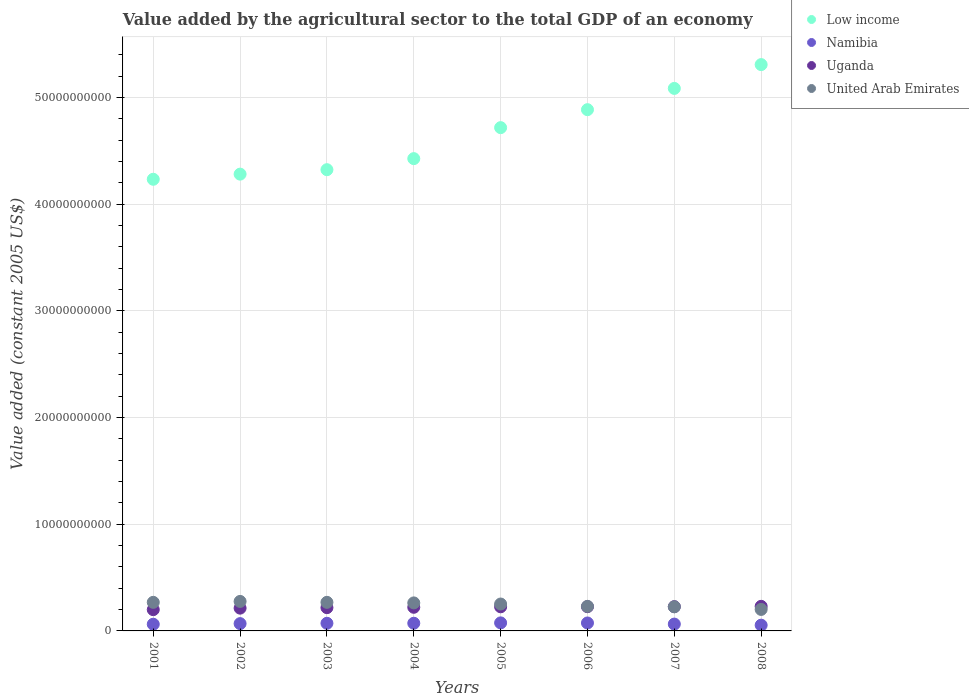How many different coloured dotlines are there?
Offer a terse response. 4. What is the value added by the agricultural sector in Low income in 2005?
Your answer should be very brief. 4.72e+1. Across all years, what is the maximum value added by the agricultural sector in Low income?
Give a very brief answer. 5.31e+1. Across all years, what is the minimum value added by the agricultural sector in United Arab Emirates?
Your response must be concise. 2.01e+09. In which year was the value added by the agricultural sector in Low income maximum?
Offer a terse response. 2008. In which year was the value added by the agricultural sector in Low income minimum?
Keep it short and to the point. 2001. What is the total value added by the agricultural sector in Uganda in the graph?
Offer a very short reply. 1.76e+1. What is the difference between the value added by the agricultural sector in Uganda in 2002 and that in 2004?
Offer a terse response. -8.03e+07. What is the difference between the value added by the agricultural sector in Namibia in 2004 and the value added by the agricultural sector in Low income in 2003?
Provide a short and direct response. -4.25e+1. What is the average value added by the agricultural sector in United Arab Emirates per year?
Keep it short and to the point. 2.48e+09. In the year 2004, what is the difference between the value added by the agricultural sector in Uganda and value added by the agricultural sector in United Arab Emirates?
Offer a terse response. -4.11e+08. What is the ratio of the value added by the agricultural sector in Low income in 2004 to that in 2005?
Provide a succinct answer. 0.94. Is the difference between the value added by the agricultural sector in Uganda in 2003 and 2006 greater than the difference between the value added by the agricultural sector in United Arab Emirates in 2003 and 2006?
Provide a short and direct response. No. What is the difference between the highest and the second highest value added by the agricultural sector in Uganda?
Offer a very short reply. 3.06e+07. What is the difference between the highest and the lowest value added by the agricultural sector in Uganda?
Provide a short and direct response. 3.10e+08. In how many years, is the value added by the agricultural sector in Uganda greater than the average value added by the agricultural sector in Uganda taken over all years?
Provide a short and direct response. 5. Is the sum of the value added by the agricultural sector in Namibia in 2001 and 2007 greater than the maximum value added by the agricultural sector in Uganda across all years?
Provide a short and direct response. No. Is it the case that in every year, the sum of the value added by the agricultural sector in Low income and value added by the agricultural sector in United Arab Emirates  is greater than the sum of value added by the agricultural sector in Namibia and value added by the agricultural sector in Uganda?
Offer a terse response. Yes. Is it the case that in every year, the sum of the value added by the agricultural sector in United Arab Emirates and value added by the agricultural sector in Low income  is greater than the value added by the agricultural sector in Namibia?
Your answer should be very brief. Yes. Does the value added by the agricultural sector in Namibia monotonically increase over the years?
Ensure brevity in your answer.  No. How many years are there in the graph?
Provide a succinct answer. 8. What is the difference between two consecutive major ticks on the Y-axis?
Give a very brief answer. 1.00e+1. Does the graph contain any zero values?
Provide a succinct answer. No. Where does the legend appear in the graph?
Give a very brief answer. Top right. How are the legend labels stacked?
Provide a short and direct response. Vertical. What is the title of the graph?
Ensure brevity in your answer.  Value added by the agricultural sector to the total GDP of an economy. What is the label or title of the Y-axis?
Your answer should be very brief. Value added (constant 2005 US$). What is the Value added (constant 2005 US$) in Low income in 2001?
Offer a terse response. 4.23e+1. What is the Value added (constant 2005 US$) of Namibia in 2001?
Give a very brief answer. 6.26e+08. What is the Value added (constant 2005 US$) in Uganda in 2001?
Provide a succinct answer. 1.99e+09. What is the Value added (constant 2005 US$) of United Arab Emirates in 2001?
Keep it short and to the point. 2.68e+09. What is the Value added (constant 2005 US$) of Low income in 2002?
Your answer should be very brief. 4.28e+1. What is the Value added (constant 2005 US$) in Namibia in 2002?
Ensure brevity in your answer.  6.85e+08. What is the Value added (constant 2005 US$) of Uganda in 2002?
Provide a succinct answer. 2.13e+09. What is the Value added (constant 2005 US$) in United Arab Emirates in 2002?
Make the answer very short. 2.76e+09. What is the Value added (constant 2005 US$) in Low income in 2003?
Provide a short and direct response. 4.32e+1. What is the Value added (constant 2005 US$) in Namibia in 2003?
Your answer should be compact. 7.16e+08. What is the Value added (constant 2005 US$) in Uganda in 2003?
Ensure brevity in your answer.  2.18e+09. What is the Value added (constant 2005 US$) in United Arab Emirates in 2003?
Keep it short and to the point. 2.68e+09. What is the Value added (constant 2005 US$) in Low income in 2004?
Ensure brevity in your answer.  4.43e+1. What is the Value added (constant 2005 US$) in Namibia in 2004?
Offer a terse response. 7.20e+08. What is the Value added (constant 2005 US$) of Uganda in 2004?
Ensure brevity in your answer.  2.21e+09. What is the Value added (constant 2005 US$) in United Arab Emirates in 2004?
Give a very brief answer. 2.63e+09. What is the Value added (constant 2005 US$) of Low income in 2005?
Your answer should be very brief. 4.72e+1. What is the Value added (constant 2005 US$) of Namibia in 2005?
Your answer should be very brief. 7.54e+08. What is the Value added (constant 2005 US$) in Uganda in 2005?
Make the answer very short. 2.26e+09. What is the Value added (constant 2005 US$) in United Arab Emirates in 2005?
Keep it short and to the point. 2.52e+09. What is the Value added (constant 2005 US$) of Low income in 2006?
Your response must be concise. 4.88e+1. What is the Value added (constant 2005 US$) in Namibia in 2006?
Provide a short and direct response. 7.45e+08. What is the Value added (constant 2005 US$) in Uganda in 2006?
Provide a short and direct response. 2.27e+09. What is the Value added (constant 2005 US$) in United Arab Emirates in 2006?
Ensure brevity in your answer.  2.30e+09. What is the Value added (constant 2005 US$) of Low income in 2007?
Provide a short and direct response. 5.08e+1. What is the Value added (constant 2005 US$) in Namibia in 2007?
Offer a terse response. 6.41e+08. What is the Value added (constant 2005 US$) in Uganda in 2007?
Keep it short and to the point. 2.27e+09. What is the Value added (constant 2005 US$) of United Arab Emirates in 2007?
Provide a succinct answer. 2.26e+09. What is the Value added (constant 2005 US$) in Low income in 2008?
Your answer should be compact. 5.31e+1. What is the Value added (constant 2005 US$) of Namibia in 2008?
Provide a succinct answer. 5.39e+08. What is the Value added (constant 2005 US$) of Uganda in 2008?
Your answer should be very brief. 2.30e+09. What is the Value added (constant 2005 US$) in United Arab Emirates in 2008?
Give a very brief answer. 2.01e+09. Across all years, what is the maximum Value added (constant 2005 US$) in Low income?
Provide a short and direct response. 5.31e+1. Across all years, what is the maximum Value added (constant 2005 US$) in Namibia?
Your response must be concise. 7.54e+08. Across all years, what is the maximum Value added (constant 2005 US$) in Uganda?
Ensure brevity in your answer.  2.30e+09. Across all years, what is the maximum Value added (constant 2005 US$) in United Arab Emirates?
Provide a short and direct response. 2.76e+09. Across all years, what is the minimum Value added (constant 2005 US$) of Low income?
Provide a succinct answer. 4.23e+1. Across all years, what is the minimum Value added (constant 2005 US$) of Namibia?
Make the answer very short. 5.39e+08. Across all years, what is the minimum Value added (constant 2005 US$) of Uganda?
Keep it short and to the point. 1.99e+09. Across all years, what is the minimum Value added (constant 2005 US$) in United Arab Emirates?
Provide a succinct answer. 2.01e+09. What is the total Value added (constant 2005 US$) in Low income in the graph?
Your answer should be compact. 3.73e+11. What is the total Value added (constant 2005 US$) in Namibia in the graph?
Your answer should be compact. 5.43e+09. What is the total Value added (constant 2005 US$) of Uganda in the graph?
Keep it short and to the point. 1.76e+1. What is the total Value added (constant 2005 US$) of United Arab Emirates in the graph?
Keep it short and to the point. 1.98e+1. What is the difference between the Value added (constant 2005 US$) in Low income in 2001 and that in 2002?
Your answer should be very brief. -4.82e+08. What is the difference between the Value added (constant 2005 US$) in Namibia in 2001 and that in 2002?
Provide a short and direct response. -5.86e+07. What is the difference between the Value added (constant 2005 US$) of Uganda in 2001 and that in 2002?
Your answer should be very brief. -1.41e+08. What is the difference between the Value added (constant 2005 US$) of United Arab Emirates in 2001 and that in 2002?
Provide a succinct answer. -8.60e+07. What is the difference between the Value added (constant 2005 US$) of Low income in 2001 and that in 2003?
Give a very brief answer. -8.99e+08. What is the difference between the Value added (constant 2005 US$) of Namibia in 2001 and that in 2003?
Ensure brevity in your answer.  -8.93e+07. What is the difference between the Value added (constant 2005 US$) of Uganda in 2001 and that in 2003?
Provide a short and direct response. -1.87e+08. What is the difference between the Value added (constant 2005 US$) in United Arab Emirates in 2001 and that in 2003?
Your answer should be very brief. 0. What is the difference between the Value added (constant 2005 US$) in Low income in 2001 and that in 2004?
Your answer should be very brief. -1.94e+09. What is the difference between the Value added (constant 2005 US$) in Namibia in 2001 and that in 2004?
Provide a short and direct response. -9.38e+07. What is the difference between the Value added (constant 2005 US$) in Uganda in 2001 and that in 2004?
Offer a terse response. -2.21e+08. What is the difference between the Value added (constant 2005 US$) in United Arab Emirates in 2001 and that in 2004?
Offer a very short reply. 5.28e+07. What is the difference between the Value added (constant 2005 US$) in Low income in 2001 and that in 2005?
Ensure brevity in your answer.  -4.84e+09. What is the difference between the Value added (constant 2005 US$) in Namibia in 2001 and that in 2005?
Give a very brief answer. -1.27e+08. What is the difference between the Value added (constant 2005 US$) of Uganda in 2001 and that in 2005?
Give a very brief answer. -2.67e+08. What is the difference between the Value added (constant 2005 US$) in United Arab Emirates in 2001 and that in 2005?
Provide a succinct answer. 1.58e+08. What is the difference between the Value added (constant 2005 US$) in Low income in 2001 and that in 2006?
Your answer should be compact. -6.52e+09. What is the difference between the Value added (constant 2005 US$) in Namibia in 2001 and that in 2006?
Offer a terse response. -1.19e+08. What is the difference between the Value added (constant 2005 US$) of Uganda in 2001 and that in 2006?
Offer a terse response. -2.77e+08. What is the difference between the Value added (constant 2005 US$) of United Arab Emirates in 2001 and that in 2006?
Your response must be concise. 3.76e+08. What is the difference between the Value added (constant 2005 US$) in Low income in 2001 and that in 2007?
Provide a short and direct response. -8.52e+09. What is the difference between the Value added (constant 2005 US$) of Namibia in 2001 and that in 2007?
Your response must be concise. -1.44e+07. What is the difference between the Value added (constant 2005 US$) of Uganda in 2001 and that in 2007?
Offer a terse response. -2.80e+08. What is the difference between the Value added (constant 2005 US$) in United Arab Emirates in 2001 and that in 2007?
Offer a very short reply. 4.19e+08. What is the difference between the Value added (constant 2005 US$) of Low income in 2001 and that in 2008?
Make the answer very short. -1.07e+1. What is the difference between the Value added (constant 2005 US$) in Namibia in 2001 and that in 2008?
Keep it short and to the point. 8.74e+07. What is the difference between the Value added (constant 2005 US$) of Uganda in 2001 and that in 2008?
Provide a short and direct response. -3.10e+08. What is the difference between the Value added (constant 2005 US$) of United Arab Emirates in 2001 and that in 2008?
Your answer should be compact. 6.65e+08. What is the difference between the Value added (constant 2005 US$) in Low income in 2002 and that in 2003?
Keep it short and to the point. -4.17e+08. What is the difference between the Value added (constant 2005 US$) of Namibia in 2002 and that in 2003?
Keep it short and to the point. -3.07e+07. What is the difference between the Value added (constant 2005 US$) in Uganda in 2002 and that in 2003?
Provide a succinct answer. -4.57e+07. What is the difference between the Value added (constant 2005 US$) of United Arab Emirates in 2002 and that in 2003?
Provide a succinct answer. 8.60e+07. What is the difference between the Value added (constant 2005 US$) in Low income in 2002 and that in 2004?
Keep it short and to the point. -1.45e+09. What is the difference between the Value added (constant 2005 US$) of Namibia in 2002 and that in 2004?
Give a very brief answer. -3.52e+07. What is the difference between the Value added (constant 2005 US$) in Uganda in 2002 and that in 2004?
Keep it short and to the point. -8.03e+07. What is the difference between the Value added (constant 2005 US$) in United Arab Emirates in 2002 and that in 2004?
Provide a short and direct response. 1.39e+08. What is the difference between the Value added (constant 2005 US$) of Low income in 2002 and that in 2005?
Provide a succinct answer. -4.36e+09. What is the difference between the Value added (constant 2005 US$) in Namibia in 2002 and that in 2005?
Offer a terse response. -6.85e+07. What is the difference between the Value added (constant 2005 US$) in Uganda in 2002 and that in 2005?
Your answer should be compact. -1.26e+08. What is the difference between the Value added (constant 2005 US$) in United Arab Emirates in 2002 and that in 2005?
Your answer should be very brief. 2.44e+08. What is the difference between the Value added (constant 2005 US$) of Low income in 2002 and that in 2006?
Offer a very short reply. -6.04e+09. What is the difference between the Value added (constant 2005 US$) of Namibia in 2002 and that in 2006?
Your response must be concise. -6.00e+07. What is the difference between the Value added (constant 2005 US$) in Uganda in 2002 and that in 2006?
Provide a short and direct response. -1.36e+08. What is the difference between the Value added (constant 2005 US$) in United Arab Emirates in 2002 and that in 2006?
Give a very brief answer. 4.62e+08. What is the difference between the Value added (constant 2005 US$) in Low income in 2002 and that in 2007?
Offer a terse response. -8.03e+09. What is the difference between the Value added (constant 2005 US$) of Namibia in 2002 and that in 2007?
Provide a short and direct response. 4.42e+07. What is the difference between the Value added (constant 2005 US$) in Uganda in 2002 and that in 2007?
Keep it short and to the point. -1.39e+08. What is the difference between the Value added (constant 2005 US$) in United Arab Emirates in 2002 and that in 2007?
Your answer should be very brief. 5.05e+08. What is the difference between the Value added (constant 2005 US$) in Low income in 2002 and that in 2008?
Provide a succinct answer. -1.03e+1. What is the difference between the Value added (constant 2005 US$) in Namibia in 2002 and that in 2008?
Offer a very short reply. 1.46e+08. What is the difference between the Value added (constant 2005 US$) in Uganda in 2002 and that in 2008?
Your response must be concise. -1.69e+08. What is the difference between the Value added (constant 2005 US$) in United Arab Emirates in 2002 and that in 2008?
Offer a terse response. 7.51e+08. What is the difference between the Value added (constant 2005 US$) in Low income in 2003 and that in 2004?
Your answer should be compact. -1.04e+09. What is the difference between the Value added (constant 2005 US$) in Namibia in 2003 and that in 2004?
Provide a succinct answer. -4.52e+06. What is the difference between the Value added (constant 2005 US$) in Uganda in 2003 and that in 2004?
Your response must be concise. -3.46e+07. What is the difference between the Value added (constant 2005 US$) in United Arab Emirates in 2003 and that in 2004?
Offer a terse response. 5.28e+07. What is the difference between the Value added (constant 2005 US$) in Low income in 2003 and that in 2005?
Ensure brevity in your answer.  -3.94e+09. What is the difference between the Value added (constant 2005 US$) in Namibia in 2003 and that in 2005?
Your response must be concise. -3.79e+07. What is the difference between the Value added (constant 2005 US$) in Uganda in 2003 and that in 2005?
Offer a terse response. -8.00e+07. What is the difference between the Value added (constant 2005 US$) in United Arab Emirates in 2003 and that in 2005?
Your answer should be compact. 1.58e+08. What is the difference between the Value added (constant 2005 US$) in Low income in 2003 and that in 2006?
Your answer should be compact. -5.62e+09. What is the difference between the Value added (constant 2005 US$) in Namibia in 2003 and that in 2006?
Provide a succinct answer. -2.93e+07. What is the difference between the Value added (constant 2005 US$) in Uganda in 2003 and that in 2006?
Offer a terse response. -9.04e+07. What is the difference between the Value added (constant 2005 US$) in United Arab Emirates in 2003 and that in 2006?
Provide a succinct answer. 3.76e+08. What is the difference between the Value added (constant 2005 US$) of Low income in 2003 and that in 2007?
Offer a terse response. -7.62e+09. What is the difference between the Value added (constant 2005 US$) of Namibia in 2003 and that in 2007?
Your answer should be compact. 7.49e+07. What is the difference between the Value added (constant 2005 US$) in Uganda in 2003 and that in 2007?
Offer a very short reply. -9.31e+07. What is the difference between the Value added (constant 2005 US$) of United Arab Emirates in 2003 and that in 2007?
Your response must be concise. 4.19e+08. What is the difference between the Value added (constant 2005 US$) of Low income in 2003 and that in 2008?
Make the answer very short. -9.85e+09. What is the difference between the Value added (constant 2005 US$) of Namibia in 2003 and that in 2008?
Your answer should be very brief. 1.77e+08. What is the difference between the Value added (constant 2005 US$) in Uganda in 2003 and that in 2008?
Give a very brief answer. -1.24e+08. What is the difference between the Value added (constant 2005 US$) of United Arab Emirates in 2003 and that in 2008?
Your answer should be compact. 6.65e+08. What is the difference between the Value added (constant 2005 US$) in Low income in 2004 and that in 2005?
Ensure brevity in your answer.  -2.90e+09. What is the difference between the Value added (constant 2005 US$) of Namibia in 2004 and that in 2005?
Your response must be concise. -3.33e+07. What is the difference between the Value added (constant 2005 US$) in Uganda in 2004 and that in 2005?
Your response must be concise. -4.54e+07. What is the difference between the Value added (constant 2005 US$) of United Arab Emirates in 2004 and that in 2005?
Your answer should be compact. 1.06e+08. What is the difference between the Value added (constant 2005 US$) of Low income in 2004 and that in 2006?
Your answer should be compact. -4.59e+09. What is the difference between the Value added (constant 2005 US$) in Namibia in 2004 and that in 2006?
Make the answer very short. -2.48e+07. What is the difference between the Value added (constant 2005 US$) in Uganda in 2004 and that in 2006?
Offer a terse response. -5.58e+07. What is the difference between the Value added (constant 2005 US$) in United Arab Emirates in 2004 and that in 2006?
Give a very brief answer. 3.23e+08. What is the difference between the Value added (constant 2005 US$) of Low income in 2004 and that in 2007?
Offer a very short reply. -6.58e+09. What is the difference between the Value added (constant 2005 US$) of Namibia in 2004 and that in 2007?
Provide a short and direct response. 7.94e+07. What is the difference between the Value added (constant 2005 US$) in Uganda in 2004 and that in 2007?
Provide a short and direct response. -5.85e+07. What is the difference between the Value added (constant 2005 US$) of United Arab Emirates in 2004 and that in 2007?
Your answer should be very brief. 3.66e+08. What is the difference between the Value added (constant 2005 US$) of Low income in 2004 and that in 2008?
Provide a succinct answer. -8.81e+09. What is the difference between the Value added (constant 2005 US$) of Namibia in 2004 and that in 2008?
Make the answer very short. 1.81e+08. What is the difference between the Value added (constant 2005 US$) of Uganda in 2004 and that in 2008?
Keep it short and to the point. -8.91e+07. What is the difference between the Value added (constant 2005 US$) in United Arab Emirates in 2004 and that in 2008?
Keep it short and to the point. 6.12e+08. What is the difference between the Value added (constant 2005 US$) of Low income in 2005 and that in 2006?
Give a very brief answer. -1.68e+09. What is the difference between the Value added (constant 2005 US$) in Namibia in 2005 and that in 2006?
Ensure brevity in your answer.  8.55e+06. What is the difference between the Value added (constant 2005 US$) in Uganda in 2005 and that in 2006?
Your answer should be very brief. -1.04e+07. What is the difference between the Value added (constant 2005 US$) of United Arab Emirates in 2005 and that in 2006?
Your answer should be very brief. 2.18e+08. What is the difference between the Value added (constant 2005 US$) of Low income in 2005 and that in 2007?
Provide a short and direct response. -3.68e+09. What is the difference between the Value added (constant 2005 US$) in Namibia in 2005 and that in 2007?
Provide a short and direct response. 1.13e+08. What is the difference between the Value added (constant 2005 US$) of Uganda in 2005 and that in 2007?
Offer a very short reply. -1.31e+07. What is the difference between the Value added (constant 2005 US$) of United Arab Emirates in 2005 and that in 2007?
Provide a short and direct response. 2.60e+08. What is the difference between the Value added (constant 2005 US$) in Low income in 2005 and that in 2008?
Ensure brevity in your answer.  -5.91e+09. What is the difference between the Value added (constant 2005 US$) of Namibia in 2005 and that in 2008?
Ensure brevity in your answer.  2.15e+08. What is the difference between the Value added (constant 2005 US$) in Uganda in 2005 and that in 2008?
Provide a succinct answer. -4.37e+07. What is the difference between the Value added (constant 2005 US$) in United Arab Emirates in 2005 and that in 2008?
Provide a short and direct response. 5.06e+08. What is the difference between the Value added (constant 2005 US$) of Low income in 2006 and that in 2007?
Your answer should be very brief. -1.99e+09. What is the difference between the Value added (constant 2005 US$) in Namibia in 2006 and that in 2007?
Ensure brevity in your answer.  1.04e+08. What is the difference between the Value added (constant 2005 US$) in Uganda in 2006 and that in 2007?
Ensure brevity in your answer.  -2.71e+06. What is the difference between the Value added (constant 2005 US$) of United Arab Emirates in 2006 and that in 2007?
Your response must be concise. 4.25e+07. What is the difference between the Value added (constant 2005 US$) in Low income in 2006 and that in 2008?
Your answer should be compact. -4.22e+09. What is the difference between the Value added (constant 2005 US$) of Namibia in 2006 and that in 2008?
Your answer should be very brief. 2.06e+08. What is the difference between the Value added (constant 2005 US$) in Uganda in 2006 and that in 2008?
Your answer should be very brief. -3.33e+07. What is the difference between the Value added (constant 2005 US$) in United Arab Emirates in 2006 and that in 2008?
Keep it short and to the point. 2.89e+08. What is the difference between the Value added (constant 2005 US$) in Low income in 2007 and that in 2008?
Keep it short and to the point. -2.23e+09. What is the difference between the Value added (constant 2005 US$) of Namibia in 2007 and that in 2008?
Your response must be concise. 1.02e+08. What is the difference between the Value added (constant 2005 US$) of Uganda in 2007 and that in 2008?
Give a very brief answer. -3.06e+07. What is the difference between the Value added (constant 2005 US$) of United Arab Emirates in 2007 and that in 2008?
Ensure brevity in your answer.  2.46e+08. What is the difference between the Value added (constant 2005 US$) in Low income in 2001 and the Value added (constant 2005 US$) in Namibia in 2002?
Provide a succinct answer. 4.16e+1. What is the difference between the Value added (constant 2005 US$) in Low income in 2001 and the Value added (constant 2005 US$) in Uganda in 2002?
Offer a very short reply. 4.02e+1. What is the difference between the Value added (constant 2005 US$) of Low income in 2001 and the Value added (constant 2005 US$) of United Arab Emirates in 2002?
Keep it short and to the point. 3.96e+1. What is the difference between the Value added (constant 2005 US$) of Namibia in 2001 and the Value added (constant 2005 US$) of Uganda in 2002?
Keep it short and to the point. -1.51e+09. What is the difference between the Value added (constant 2005 US$) of Namibia in 2001 and the Value added (constant 2005 US$) of United Arab Emirates in 2002?
Offer a very short reply. -2.14e+09. What is the difference between the Value added (constant 2005 US$) of Uganda in 2001 and the Value added (constant 2005 US$) of United Arab Emirates in 2002?
Offer a terse response. -7.71e+08. What is the difference between the Value added (constant 2005 US$) in Low income in 2001 and the Value added (constant 2005 US$) in Namibia in 2003?
Offer a terse response. 4.16e+1. What is the difference between the Value added (constant 2005 US$) of Low income in 2001 and the Value added (constant 2005 US$) of Uganda in 2003?
Provide a succinct answer. 4.01e+1. What is the difference between the Value added (constant 2005 US$) in Low income in 2001 and the Value added (constant 2005 US$) in United Arab Emirates in 2003?
Offer a terse response. 3.96e+1. What is the difference between the Value added (constant 2005 US$) in Namibia in 2001 and the Value added (constant 2005 US$) in Uganda in 2003?
Your answer should be very brief. -1.55e+09. What is the difference between the Value added (constant 2005 US$) in Namibia in 2001 and the Value added (constant 2005 US$) in United Arab Emirates in 2003?
Offer a very short reply. -2.05e+09. What is the difference between the Value added (constant 2005 US$) of Uganda in 2001 and the Value added (constant 2005 US$) of United Arab Emirates in 2003?
Your answer should be compact. -6.85e+08. What is the difference between the Value added (constant 2005 US$) of Low income in 2001 and the Value added (constant 2005 US$) of Namibia in 2004?
Provide a short and direct response. 4.16e+1. What is the difference between the Value added (constant 2005 US$) in Low income in 2001 and the Value added (constant 2005 US$) in Uganda in 2004?
Provide a succinct answer. 4.01e+1. What is the difference between the Value added (constant 2005 US$) in Low income in 2001 and the Value added (constant 2005 US$) in United Arab Emirates in 2004?
Give a very brief answer. 3.97e+1. What is the difference between the Value added (constant 2005 US$) in Namibia in 2001 and the Value added (constant 2005 US$) in Uganda in 2004?
Provide a succinct answer. -1.59e+09. What is the difference between the Value added (constant 2005 US$) of Namibia in 2001 and the Value added (constant 2005 US$) of United Arab Emirates in 2004?
Your answer should be very brief. -2.00e+09. What is the difference between the Value added (constant 2005 US$) of Uganda in 2001 and the Value added (constant 2005 US$) of United Arab Emirates in 2004?
Give a very brief answer. -6.32e+08. What is the difference between the Value added (constant 2005 US$) in Low income in 2001 and the Value added (constant 2005 US$) in Namibia in 2005?
Provide a succinct answer. 4.16e+1. What is the difference between the Value added (constant 2005 US$) of Low income in 2001 and the Value added (constant 2005 US$) of Uganda in 2005?
Provide a short and direct response. 4.01e+1. What is the difference between the Value added (constant 2005 US$) of Low income in 2001 and the Value added (constant 2005 US$) of United Arab Emirates in 2005?
Your response must be concise. 3.98e+1. What is the difference between the Value added (constant 2005 US$) in Namibia in 2001 and the Value added (constant 2005 US$) in Uganda in 2005?
Give a very brief answer. -1.63e+09. What is the difference between the Value added (constant 2005 US$) of Namibia in 2001 and the Value added (constant 2005 US$) of United Arab Emirates in 2005?
Provide a short and direct response. -1.89e+09. What is the difference between the Value added (constant 2005 US$) in Uganda in 2001 and the Value added (constant 2005 US$) in United Arab Emirates in 2005?
Provide a succinct answer. -5.27e+08. What is the difference between the Value added (constant 2005 US$) of Low income in 2001 and the Value added (constant 2005 US$) of Namibia in 2006?
Your answer should be compact. 4.16e+1. What is the difference between the Value added (constant 2005 US$) in Low income in 2001 and the Value added (constant 2005 US$) in Uganda in 2006?
Offer a terse response. 4.01e+1. What is the difference between the Value added (constant 2005 US$) of Low income in 2001 and the Value added (constant 2005 US$) of United Arab Emirates in 2006?
Make the answer very short. 4.00e+1. What is the difference between the Value added (constant 2005 US$) of Namibia in 2001 and the Value added (constant 2005 US$) of Uganda in 2006?
Offer a terse response. -1.64e+09. What is the difference between the Value added (constant 2005 US$) in Namibia in 2001 and the Value added (constant 2005 US$) in United Arab Emirates in 2006?
Offer a very short reply. -1.68e+09. What is the difference between the Value added (constant 2005 US$) in Uganda in 2001 and the Value added (constant 2005 US$) in United Arab Emirates in 2006?
Provide a succinct answer. -3.09e+08. What is the difference between the Value added (constant 2005 US$) in Low income in 2001 and the Value added (constant 2005 US$) in Namibia in 2007?
Make the answer very short. 4.17e+1. What is the difference between the Value added (constant 2005 US$) in Low income in 2001 and the Value added (constant 2005 US$) in Uganda in 2007?
Keep it short and to the point. 4.01e+1. What is the difference between the Value added (constant 2005 US$) in Low income in 2001 and the Value added (constant 2005 US$) in United Arab Emirates in 2007?
Give a very brief answer. 4.01e+1. What is the difference between the Value added (constant 2005 US$) in Namibia in 2001 and the Value added (constant 2005 US$) in Uganda in 2007?
Make the answer very short. -1.65e+09. What is the difference between the Value added (constant 2005 US$) in Namibia in 2001 and the Value added (constant 2005 US$) in United Arab Emirates in 2007?
Your response must be concise. -1.63e+09. What is the difference between the Value added (constant 2005 US$) in Uganda in 2001 and the Value added (constant 2005 US$) in United Arab Emirates in 2007?
Offer a terse response. -2.67e+08. What is the difference between the Value added (constant 2005 US$) of Low income in 2001 and the Value added (constant 2005 US$) of Namibia in 2008?
Your answer should be compact. 4.18e+1. What is the difference between the Value added (constant 2005 US$) in Low income in 2001 and the Value added (constant 2005 US$) in Uganda in 2008?
Keep it short and to the point. 4.00e+1. What is the difference between the Value added (constant 2005 US$) in Low income in 2001 and the Value added (constant 2005 US$) in United Arab Emirates in 2008?
Make the answer very short. 4.03e+1. What is the difference between the Value added (constant 2005 US$) in Namibia in 2001 and the Value added (constant 2005 US$) in Uganda in 2008?
Keep it short and to the point. -1.68e+09. What is the difference between the Value added (constant 2005 US$) in Namibia in 2001 and the Value added (constant 2005 US$) in United Arab Emirates in 2008?
Your answer should be very brief. -1.39e+09. What is the difference between the Value added (constant 2005 US$) of Uganda in 2001 and the Value added (constant 2005 US$) of United Arab Emirates in 2008?
Make the answer very short. -2.03e+07. What is the difference between the Value added (constant 2005 US$) in Low income in 2002 and the Value added (constant 2005 US$) in Namibia in 2003?
Your response must be concise. 4.21e+1. What is the difference between the Value added (constant 2005 US$) in Low income in 2002 and the Value added (constant 2005 US$) in Uganda in 2003?
Provide a succinct answer. 4.06e+1. What is the difference between the Value added (constant 2005 US$) in Low income in 2002 and the Value added (constant 2005 US$) in United Arab Emirates in 2003?
Offer a very short reply. 4.01e+1. What is the difference between the Value added (constant 2005 US$) in Namibia in 2002 and the Value added (constant 2005 US$) in Uganda in 2003?
Ensure brevity in your answer.  -1.50e+09. What is the difference between the Value added (constant 2005 US$) of Namibia in 2002 and the Value added (constant 2005 US$) of United Arab Emirates in 2003?
Your response must be concise. -1.99e+09. What is the difference between the Value added (constant 2005 US$) of Uganda in 2002 and the Value added (constant 2005 US$) of United Arab Emirates in 2003?
Your answer should be very brief. -5.44e+08. What is the difference between the Value added (constant 2005 US$) of Low income in 2002 and the Value added (constant 2005 US$) of Namibia in 2004?
Provide a succinct answer. 4.21e+1. What is the difference between the Value added (constant 2005 US$) of Low income in 2002 and the Value added (constant 2005 US$) of Uganda in 2004?
Give a very brief answer. 4.06e+1. What is the difference between the Value added (constant 2005 US$) of Low income in 2002 and the Value added (constant 2005 US$) of United Arab Emirates in 2004?
Your answer should be compact. 4.02e+1. What is the difference between the Value added (constant 2005 US$) of Namibia in 2002 and the Value added (constant 2005 US$) of Uganda in 2004?
Provide a short and direct response. -1.53e+09. What is the difference between the Value added (constant 2005 US$) in Namibia in 2002 and the Value added (constant 2005 US$) in United Arab Emirates in 2004?
Provide a succinct answer. -1.94e+09. What is the difference between the Value added (constant 2005 US$) in Uganda in 2002 and the Value added (constant 2005 US$) in United Arab Emirates in 2004?
Offer a very short reply. -4.91e+08. What is the difference between the Value added (constant 2005 US$) in Low income in 2002 and the Value added (constant 2005 US$) in Namibia in 2005?
Offer a terse response. 4.21e+1. What is the difference between the Value added (constant 2005 US$) of Low income in 2002 and the Value added (constant 2005 US$) of Uganda in 2005?
Make the answer very short. 4.05e+1. What is the difference between the Value added (constant 2005 US$) of Low income in 2002 and the Value added (constant 2005 US$) of United Arab Emirates in 2005?
Your answer should be compact. 4.03e+1. What is the difference between the Value added (constant 2005 US$) of Namibia in 2002 and the Value added (constant 2005 US$) of Uganda in 2005?
Offer a very short reply. -1.58e+09. What is the difference between the Value added (constant 2005 US$) of Namibia in 2002 and the Value added (constant 2005 US$) of United Arab Emirates in 2005?
Keep it short and to the point. -1.84e+09. What is the difference between the Value added (constant 2005 US$) of Uganda in 2002 and the Value added (constant 2005 US$) of United Arab Emirates in 2005?
Your answer should be compact. -3.86e+08. What is the difference between the Value added (constant 2005 US$) of Low income in 2002 and the Value added (constant 2005 US$) of Namibia in 2006?
Your response must be concise. 4.21e+1. What is the difference between the Value added (constant 2005 US$) of Low income in 2002 and the Value added (constant 2005 US$) of Uganda in 2006?
Ensure brevity in your answer.  4.05e+1. What is the difference between the Value added (constant 2005 US$) in Low income in 2002 and the Value added (constant 2005 US$) in United Arab Emirates in 2006?
Provide a short and direct response. 4.05e+1. What is the difference between the Value added (constant 2005 US$) in Namibia in 2002 and the Value added (constant 2005 US$) in Uganda in 2006?
Offer a terse response. -1.59e+09. What is the difference between the Value added (constant 2005 US$) in Namibia in 2002 and the Value added (constant 2005 US$) in United Arab Emirates in 2006?
Provide a succinct answer. -1.62e+09. What is the difference between the Value added (constant 2005 US$) in Uganda in 2002 and the Value added (constant 2005 US$) in United Arab Emirates in 2006?
Provide a succinct answer. -1.68e+08. What is the difference between the Value added (constant 2005 US$) in Low income in 2002 and the Value added (constant 2005 US$) in Namibia in 2007?
Your answer should be very brief. 4.22e+1. What is the difference between the Value added (constant 2005 US$) in Low income in 2002 and the Value added (constant 2005 US$) in Uganda in 2007?
Your answer should be very brief. 4.05e+1. What is the difference between the Value added (constant 2005 US$) of Low income in 2002 and the Value added (constant 2005 US$) of United Arab Emirates in 2007?
Your answer should be very brief. 4.05e+1. What is the difference between the Value added (constant 2005 US$) of Namibia in 2002 and the Value added (constant 2005 US$) of Uganda in 2007?
Make the answer very short. -1.59e+09. What is the difference between the Value added (constant 2005 US$) of Namibia in 2002 and the Value added (constant 2005 US$) of United Arab Emirates in 2007?
Give a very brief answer. -1.58e+09. What is the difference between the Value added (constant 2005 US$) of Uganda in 2002 and the Value added (constant 2005 US$) of United Arab Emirates in 2007?
Your answer should be very brief. -1.26e+08. What is the difference between the Value added (constant 2005 US$) of Low income in 2002 and the Value added (constant 2005 US$) of Namibia in 2008?
Provide a short and direct response. 4.23e+1. What is the difference between the Value added (constant 2005 US$) in Low income in 2002 and the Value added (constant 2005 US$) in Uganda in 2008?
Provide a short and direct response. 4.05e+1. What is the difference between the Value added (constant 2005 US$) of Low income in 2002 and the Value added (constant 2005 US$) of United Arab Emirates in 2008?
Make the answer very short. 4.08e+1. What is the difference between the Value added (constant 2005 US$) of Namibia in 2002 and the Value added (constant 2005 US$) of Uganda in 2008?
Your answer should be compact. -1.62e+09. What is the difference between the Value added (constant 2005 US$) in Namibia in 2002 and the Value added (constant 2005 US$) in United Arab Emirates in 2008?
Ensure brevity in your answer.  -1.33e+09. What is the difference between the Value added (constant 2005 US$) of Uganda in 2002 and the Value added (constant 2005 US$) of United Arab Emirates in 2008?
Make the answer very short. 1.21e+08. What is the difference between the Value added (constant 2005 US$) in Low income in 2003 and the Value added (constant 2005 US$) in Namibia in 2004?
Keep it short and to the point. 4.25e+1. What is the difference between the Value added (constant 2005 US$) in Low income in 2003 and the Value added (constant 2005 US$) in Uganda in 2004?
Provide a short and direct response. 4.10e+1. What is the difference between the Value added (constant 2005 US$) in Low income in 2003 and the Value added (constant 2005 US$) in United Arab Emirates in 2004?
Offer a very short reply. 4.06e+1. What is the difference between the Value added (constant 2005 US$) in Namibia in 2003 and the Value added (constant 2005 US$) in Uganda in 2004?
Provide a short and direct response. -1.50e+09. What is the difference between the Value added (constant 2005 US$) of Namibia in 2003 and the Value added (constant 2005 US$) of United Arab Emirates in 2004?
Provide a succinct answer. -1.91e+09. What is the difference between the Value added (constant 2005 US$) in Uganda in 2003 and the Value added (constant 2005 US$) in United Arab Emirates in 2004?
Ensure brevity in your answer.  -4.46e+08. What is the difference between the Value added (constant 2005 US$) of Low income in 2003 and the Value added (constant 2005 US$) of Namibia in 2005?
Your answer should be very brief. 4.25e+1. What is the difference between the Value added (constant 2005 US$) of Low income in 2003 and the Value added (constant 2005 US$) of Uganda in 2005?
Make the answer very short. 4.10e+1. What is the difference between the Value added (constant 2005 US$) of Low income in 2003 and the Value added (constant 2005 US$) of United Arab Emirates in 2005?
Your answer should be very brief. 4.07e+1. What is the difference between the Value added (constant 2005 US$) in Namibia in 2003 and the Value added (constant 2005 US$) in Uganda in 2005?
Give a very brief answer. -1.54e+09. What is the difference between the Value added (constant 2005 US$) of Namibia in 2003 and the Value added (constant 2005 US$) of United Arab Emirates in 2005?
Provide a short and direct response. -1.80e+09. What is the difference between the Value added (constant 2005 US$) in Uganda in 2003 and the Value added (constant 2005 US$) in United Arab Emirates in 2005?
Provide a succinct answer. -3.40e+08. What is the difference between the Value added (constant 2005 US$) of Low income in 2003 and the Value added (constant 2005 US$) of Namibia in 2006?
Provide a short and direct response. 4.25e+1. What is the difference between the Value added (constant 2005 US$) in Low income in 2003 and the Value added (constant 2005 US$) in Uganda in 2006?
Provide a short and direct response. 4.10e+1. What is the difference between the Value added (constant 2005 US$) in Low income in 2003 and the Value added (constant 2005 US$) in United Arab Emirates in 2006?
Make the answer very short. 4.09e+1. What is the difference between the Value added (constant 2005 US$) of Namibia in 2003 and the Value added (constant 2005 US$) of Uganda in 2006?
Offer a terse response. -1.55e+09. What is the difference between the Value added (constant 2005 US$) of Namibia in 2003 and the Value added (constant 2005 US$) of United Arab Emirates in 2006?
Offer a terse response. -1.59e+09. What is the difference between the Value added (constant 2005 US$) in Uganda in 2003 and the Value added (constant 2005 US$) in United Arab Emirates in 2006?
Your answer should be very brief. -1.22e+08. What is the difference between the Value added (constant 2005 US$) in Low income in 2003 and the Value added (constant 2005 US$) in Namibia in 2007?
Your response must be concise. 4.26e+1. What is the difference between the Value added (constant 2005 US$) in Low income in 2003 and the Value added (constant 2005 US$) in Uganda in 2007?
Your response must be concise. 4.10e+1. What is the difference between the Value added (constant 2005 US$) in Low income in 2003 and the Value added (constant 2005 US$) in United Arab Emirates in 2007?
Offer a terse response. 4.10e+1. What is the difference between the Value added (constant 2005 US$) in Namibia in 2003 and the Value added (constant 2005 US$) in Uganda in 2007?
Give a very brief answer. -1.56e+09. What is the difference between the Value added (constant 2005 US$) of Namibia in 2003 and the Value added (constant 2005 US$) of United Arab Emirates in 2007?
Give a very brief answer. -1.54e+09. What is the difference between the Value added (constant 2005 US$) in Uganda in 2003 and the Value added (constant 2005 US$) in United Arab Emirates in 2007?
Offer a very short reply. -8.00e+07. What is the difference between the Value added (constant 2005 US$) of Low income in 2003 and the Value added (constant 2005 US$) of Namibia in 2008?
Give a very brief answer. 4.27e+1. What is the difference between the Value added (constant 2005 US$) of Low income in 2003 and the Value added (constant 2005 US$) of Uganda in 2008?
Keep it short and to the point. 4.09e+1. What is the difference between the Value added (constant 2005 US$) of Low income in 2003 and the Value added (constant 2005 US$) of United Arab Emirates in 2008?
Provide a short and direct response. 4.12e+1. What is the difference between the Value added (constant 2005 US$) in Namibia in 2003 and the Value added (constant 2005 US$) in Uganda in 2008?
Offer a very short reply. -1.59e+09. What is the difference between the Value added (constant 2005 US$) of Namibia in 2003 and the Value added (constant 2005 US$) of United Arab Emirates in 2008?
Give a very brief answer. -1.30e+09. What is the difference between the Value added (constant 2005 US$) of Uganda in 2003 and the Value added (constant 2005 US$) of United Arab Emirates in 2008?
Provide a short and direct response. 1.66e+08. What is the difference between the Value added (constant 2005 US$) of Low income in 2004 and the Value added (constant 2005 US$) of Namibia in 2005?
Provide a succinct answer. 4.35e+1. What is the difference between the Value added (constant 2005 US$) of Low income in 2004 and the Value added (constant 2005 US$) of Uganda in 2005?
Your response must be concise. 4.20e+1. What is the difference between the Value added (constant 2005 US$) in Low income in 2004 and the Value added (constant 2005 US$) in United Arab Emirates in 2005?
Ensure brevity in your answer.  4.17e+1. What is the difference between the Value added (constant 2005 US$) in Namibia in 2004 and the Value added (constant 2005 US$) in Uganda in 2005?
Keep it short and to the point. -1.54e+09. What is the difference between the Value added (constant 2005 US$) in Namibia in 2004 and the Value added (constant 2005 US$) in United Arab Emirates in 2005?
Provide a short and direct response. -1.80e+09. What is the difference between the Value added (constant 2005 US$) in Uganda in 2004 and the Value added (constant 2005 US$) in United Arab Emirates in 2005?
Provide a short and direct response. -3.06e+08. What is the difference between the Value added (constant 2005 US$) in Low income in 2004 and the Value added (constant 2005 US$) in Namibia in 2006?
Give a very brief answer. 4.35e+1. What is the difference between the Value added (constant 2005 US$) of Low income in 2004 and the Value added (constant 2005 US$) of Uganda in 2006?
Offer a very short reply. 4.20e+1. What is the difference between the Value added (constant 2005 US$) in Low income in 2004 and the Value added (constant 2005 US$) in United Arab Emirates in 2006?
Offer a very short reply. 4.20e+1. What is the difference between the Value added (constant 2005 US$) of Namibia in 2004 and the Value added (constant 2005 US$) of Uganda in 2006?
Keep it short and to the point. -1.55e+09. What is the difference between the Value added (constant 2005 US$) of Namibia in 2004 and the Value added (constant 2005 US$) of United Arab Emirates in 2006?
Provide a succinct answer. -1.58e+09. What is the difference between the Value added (constant 2005 US$) in Uganda in 2004 and the Value added (constant 2005 US$) in United Arab Emirates in 2006?
Provide a short and direct response. -8.78e+07. What is the difference between the Value added (constant 2005 US$) in Low income in 2004 and the Value added (constant 2005 US$) in Namibia in 2007?
Offer a terse response. 4.36e+1. What is the difference between the Value added (constant 2005 US$) in Low income in 2004 and the Value added (constant 2005 US$) in Uganda in 2007?
Your answer should be very brief. 4.20e+1. What is the difference between the Value added (constant 2005 US$) of Low income in 2004 and the Value added (constant 2005 US$) of United Arab Emirates in 2007?
Keep it short and to the point. 4.20e+1. What is the difference between the Value added (constant 2005 US$) of Namibia in 2004 and the Value added (constant 2005 US$) of Uganda in 2007?
Provide a short and direct response. -1.55e+09. What is the difference between the Value added (constant 2005 US$) of Namibia in 2004 and the Value added (constant 2005 US$) of United Arab Emirates in 2007?
Your answer should be very brief. -1.54e+09. What is the difference between the Value added (constant 2005 US$) in Uganda in 2004 and the Value added (constant 2005 US$) in United Arab Emirates in 2007?
Offer a very short reply. -4.53e+07. What is the difference between the Value added (constant 2005 US$) in Low income in 2004 and the Value added (constant 2005 US$) in Namibia in 2008?
Make the answer very short. 4.37e+1. What is the difference between the Value added (constant 2005 US$) of Low income in 2004 and the Value added (constant 2005 US$) of Uganda in 2008?
Make the answer very short. 4.20e+1. What is the difference between the Value added (constant 2005 US$) in Low income in 2004 and the Value added (constant 2005 US$) in United Arab Emirates in 2008?
Provide a succinct answer. 4.22e+1. What is the difference between the Value added (constant 2005 US$) in Namibia in 2004 and the Value added (constant 2005 US$) in Uganda in 2008?
Your answer should be compact. -1.58e+09. What is the difference between the Value added (constant 2005 US$) in Namibia in 2004 and the Value added (constant 2005 US$) in United Arab Emirates in 2008?
Your answer should be very brief. -1.29e+09. What is the difference between the Value added (constant 2005 US$) of Uganda in 2004 and the Value added (constant 2005 US$) of United Arab Emirates in 2008?
Offer a terse response. 2.01e+08. What is the difference between the Value added (constant 2005 US$) of Low income in 2005 and the Value added (constant 2005 US$) of Namibia in 2006?
Ensure brevity in your answer.  4.64e+1. What is the difference between the Value added (constant 2005 US$) in Low income in 2005 and the Value added (constant 2005 US$) in Uganda in 2006?
Ensure brevity in your answer.  4.49e+1. What is the difference between the Value added (constant 2005 US$) in Low income in 2005 and the Value added (constant 2005 US$) in United Arab Emirates in 2006?
Provide a succinct answer. 4.49e+1. What is the difference between the Value added (constant 2005 US$) in Namibia in 2005 and the Value added (constant 2005 US$) in Uganda in 2006?
Your answer should be compact. -1.52e+09. What is the difference between the Value added (constant 2005 US$) in Namibia in 2005 and the Value added (constant 2005 US$) in United Arab Emirates in 2006?
Ensure brevity in your answer.  -1.55e+09. What is the difference between the Value added (constant 2005 US$) of Uganda in 2005 and the Value added (constant 2005 US$) of United Arab Emirates in 2006?
Give a very brief answer. -4.25e+07. What is the difference between the Value added (constant 2005 US$) of Low income in 2005 and the Value added (constant 2005 US$) of Namibia in 2007?
Your answer should be compact. 4.65e+1. What is the difference between the Value added (constant 2005 US$) in Low income in 2005 and the Value added (constant 2005 US$) in Uganda in 2007?
Your answer should be compact. 4.49e+1. What is the difference between the Value added (constant 2005 US$) in Low income in 2005 and the Value added (constant 2005 US$) in United Arab Emirates in 2007?
Ensure brevity in your answer.  4.49e+1. What is the difference between the Value added (constant 2005 US$) in Namibia in 2005 and the Value added (constant 2005 US$) in Uganda in 2007?
Offer a very short reply. -1.52e+09. What is the difference between the Value added (constant 2005 US$) of Namibia in 2005 and the Value added (constant 2005 US$) of United Arab Emirates in 2007?
Make the answer very short. -1.51e+09. What is the difference between the Value added (constant 2005 US$) in Uganda in 2005 and the Value added (constant 2005 US$) in United Arab Emirates in 2007?
Provide a succinct answer. 5.48e+04. What is the difference between the Value added (constant 2005 US$) of Low income in 2005 and the Value added (constant 2005 US$) of Namibia in 2008?
Provide a short and direct response. 4.66e+1. What is the difference between the Value added (constant 2005 US$) in Low income in 2005 and the Value added (constant 2005 US$) in Uganda in 2008?
Provide a short and direct response. 4.49e+1. What is the difference between the Value added (constant 2005 US$) of Low income in 2005 and the Value added (constant 2005 US$) of United Arab Emirates in 2008?
Offer a terse response. 4.52e+1. What is the difference between the Value added (constant 2005 US$) of Namibia in 2005 and the Value added (constant 2005 US$) of Uganda in 2008?
Your answer should be compact. -1.55e+09. What is the difference between the Value added (constant 2005 US$) of Namibia in 2005 and the Value added (constant 2005 US$) of United Arab Emirates in 2008?
Ensure brevity in your answer.  -1.26e+09. What is the difference between the Value added (constant 2005 US$) of Uganda in 2005 and the Value added (constant 2005 US$) of United Arab Emirates in 2008?
Offer a very short reply. 2.46e+08. What is the difference between the Value added (constant 2005 US$) of Low income in 2006 and the Value added (constant 2005 US$) of Namibia in 2007?
Your response must be concise. 4.82e+1. What is the difference between the Value added (constant 2005 US$) in Low income in 2006 and the Value added (constant 2005 US$) in Uganda in 2007?
Offer a very short reply. 4.66e+1. What is the difference between the Value added (constant 2005 US$) in Low income in 2006 and the Value added (constant 2005 US$) in United Arab Emirates in 2007?
Your response must be concise. 4.66e+1. What is the difference between the Value added (constant 2005 US$) in Namibia in 2006 and the Value added (constant 2005 US$) in Uganda in 2007?
Ensure brevity in your answer.  -1.53e+09. What is the difference between the Value added (constant 2005 US$) in Namibia in 2006 and the Value added (constant 2005 US$) in United Arab Emirates in 2007?
Offer a very short reply. -1.52e+09. What is the difference between the Value added (constant 2005 US$) of Uganda in 2006 and the Value added (constant 2005 US$) of United Arab Emirates in 2007?
Your response must be concise. 1.04e+07. What is the difference between the Value added (constant 2005 US$) of Low income in 2006 and the Value added (constant 2005 US$) of Namibia in 2008?
Provide a short and direct response. 4.83e+1. What is the difference between the Value added (constant 2005 US$) of Low income in 2006 and the Value added (constant 2005 US$) of Uganda in 2008?
Your answer should be very brief. 4.65e+1. What is the difference between the Value added (constant 2005 US$) in Low income in 2006 and the Value added (constant 2005 US$) in United Arab Emirates in 2008?
Your answer should be very brief. 4.68e+1. What is the difference between the Value added (constant 2005 US$) of Namibia in 2006 and the Value added (constant 2005 US$) of Uganda in 2008?
Make the answer very short. -1.56e+09. What is the difference between the Value added (constant 2005 US$) of Namibia in 2006 and the Value added (constant 2005 US$) of United Arab Emirates in 2008?
Keep it short and to the point. -1.27e+09. What is the difference between the Value added (constant 2005 US$) of Uganda in 2006 and the Value added (constant 2005 US$) of United Arab Emirates in 2008?
Give a very brief answer. 2.57e+08. What is the difference between the Value added (constant 2005 US$) of Low income in 2007 and the Value added (constant 2005 US$) of Namibia in 2008?
Keep it short and to the point. 5.03e+1. What is the difference between the Value added (constant 2005 US$) of Low income in 2007 and the Value added (constant 2005 US$) of Uganda in 2008?
Offer a terse response. 4.85e+1. What is the difference between the Value added (constant 2005 US$) of Low income in 2007 and the Value added (constant 2005 US$) of United Arab Emirates in 2008?
Offer a terse response. 4.88e+1. What is the difference between the Value added (constant 2005 US$) of Namibia in 2007 and the Value added (constant 2005 US$) of Uganda in 2008?
Your response must be concise. -1.66e+09. What is the difference between the Value added (constant 2005 US$) of Namibia in 2007 and the Value added (constant 2005 US$) of United Arab Emirates in 2008?
Offer a terse response. -1.37e+09. What is the difference between the Value added (constant 2005 US$) of Uganda in 2007 and the Value added (constant 2005 US$) of United Arab Emirates in 2008?
Your response must be concise. 2.59e+08. What is the average Value added (constant 2005 US$) in Low income per year?
Your answer should be compact. 4.66e+1. What is the average Value added (constant 2005 US$) in Namibia per year?
Offer a terse response. 6.78e+08. What is the average Value added (constant 2005 US$) of Uganda per year?
Your answer should be very brief. 2.20e+09. What is the average Value added (constant 2005 US$) of United Arab Emirates per year?
Make the answer very short. 2.48e+09. In the year 2001, what is the difference between the Value added (constant 2005 US$) of Low income and Value added (constant 2005 US$) of Namibia?
Provide a short and direct response. 4.17e+1. In the year 2001, what is the difference between the Value added (constant 2005 US$) in Low income and Value added (constant 2005 US$) in Uganda?
Make the answer very short. 4.03e+1. In the year 2001, what is the difference between the Value added (constant 2005 US$) in Low income and Value added (constant 2005 US$) in United Arab Emirates?
Your answer should be very brief. 3.96e+1. In the year 2001, what is the difference between the Value added (constant 2005 US$) of Namibia and Value added (constant 2005 US$) of Uganda?
Offer a very short reply. -1.37e+09. In the year 2001, what is the difference between the Value added (constant 2005 US$) of Namibia and Value added (constant 2005 US$) of United Arab Emirates?
Make the answer very short. -2.05e+09. In the year 2001, what is the difference between the Value added (constant 2005 US$) in Uganda and Value added (constant 2005 US$) in United Arab Emirates?
Your answer should be very brief. -6.85e+08. In the year 2002, what is the difference between the Value added (constant 2005 US$) of Low income and Value added (constant 2005 US$) of Namibia?
Your response must be concise. 4.21e+1. In the year 2002, what is the difference between the Value added (constant 2005 US$) of Low income and Value added (constant 2005 US$) of Uganda?
Make the answer very short. 4.07e+1. In the year 2002, what is the difference between the Value added (constant 2005 US$) of Low income and Value added (constant 2005 US$) of United Arab Emirates?
Your answer should be compact. 4.00e+1. In the year 2002, what is the difference between the Value added (constant 2005 US$) in Namibia and Value added (constant 2005 US$) in Uganda?
Provide a succinct answer. -1.45e+09. In the year 2002, what is the difference between the Value added (constant 2005 US$) of Namibia and Value added (constant 2005 US$) of United Arab Emirates?
Provide a short and direct response. -2.08e+09. In the year 2002, what is the difference between the Value added (constant 2005 US$) of Uganda and Value added (constant 2005 US$) of United Arab Emirates?
Offer a very short reply. -6.30e+08. In the year 2003, what is the difference between the Value added (constant 2005 US$) in Low income and Value added (constant 2005 US$) in Namibia?
Your response must be concise. 4.25e+1. In the year 2003, what is the difference between the Value added (constant 2005 US$) in Low income and Value added (constant 2005 US$) in Uganda?
Give a very brief answer. 4.10e+1. In the year 2003, what is the difference between the Value added (constant 2005 US$) in Low income and Value added (constant 2005 US$) in United Arab Emirates?
Ensure brevity in your answer.  4.05e+1. In the year 2003, what is the difference between the Value added (constant 2005 US$) of Namibia and Value added (constant 2005 US$) of Uganda?
Your answer should be very brief. -1.46e+09. In the year 2003, what is the difference between the Value added (constant 2005 US$) in Namibia and Value added (constant 2005 US$) in United Arab Emirates?
Provide a short and direct response. -1.96e+09. In the year 2003, what is the difference between the Value added (constant 2005 US$) of Uganda and Value added (constant 2005 US$) of United Arab Emirates?
Ensure brevity in your answer.  -4.98e+08. In the year 2004, what is the difference between the Value added (constant 2005 US$) in Low income and Value added (constant 2005 US$) in Namibia?
Your answer should be compact. 4.35e+1. In the year 2004, what is the difference between the Value added (constant 2005 US$) of Low income and Value added (constant 2005 US$) of Uganda?
Provide a short and direct response. 4.20e+1. In the year 2004, what is the difference between the Value added (constant 2005 US$) in Low income and Value added (constant 2005 US$) in United Arab Emirates?
Make the answer very short. 4.16e+1. In the year 2004, what is the difference between the Value added (constant 2005 US$) in Namibia and Value added (constant 2005 US$) in Uganda?
Offer a terse response. -1.49e+09. In the year 2004, what is the difference between the Value added (constant 2005 US$) of Namibia and Value added (constant 2005 US$) of United Arab Emirates?
Ensure brevity in your answer.  -1.91e+09. In the year 2004, what is the difference between the Value added (constant 2005 US$) of Uganda and Value added (constant 2005 US$) of United Arab Emirates?
Give a very brief answer. -4.11e+08. In the year 2005, what is the difference between the Value added (constant 2005 US$) of Low income and Value added (constant 2005 US$) of Namibia?
Offer a terse response. 4.64e+1. In the year 2005, what is the difference between the Value added (constant 2005 US$) in Low income and Value added (constant 2005 US$) in Uganda?
Your response must be concise. 4.49e+1. In the year 2005, what is the difference between the Value added (constant 2005 US$) in Low income and Value added (constant 2005 US$) in United Arab Emirates?
Provide a succinct answer. 4.46e+1. In the year 2005, what is the difference between the Value added (constant 2005 US$) in Namibia and Value added (constant 2005 US$) in Uganda?
Give a very brief answer. -1.51e+09. In the year 2005, what is the difference between the Value added (constant 2005 US$) of Namibia and Value added (constant 2005 US$) of United Arab Emirates?
Your response must be concise. -1.77e+09. In the year 2005, what is the difference between the Value added (constant 2005 US$) in Uganda and Value added (constant 2005 US$) in United Arab Emirates?
Your answer should be compact. -2.60e+08. In the year 2006, what is the difference between the Value added (constant 2005 US$) of Low income and Value added (constant 2005 US$) of Namibia?
Offer a very short reply. 4.81e+1. In the year 2006, what is the difference between the Value added (constant 2005 US$) in Low income and Value added (constant 2005 US$) in Uganda?
Your answer should be compact. 4.66e+1. In the year 2006, what is the difference between the Value added (constant 2005 US$) in Low income and Value added (constant 2005 US$) in United Arab Emirates?
Make the answer very short. 4.65e+1. In the year 2006, what is the difference between the Value added (constant 2005 US$) of Namibia and Value added (constant 2005 US$) of Uganda?
Your answer should be compact. -1.53e+09. In the year 2006, what is the difference between the Value added (constant 2005 US$) in Namibia and Value added (constant 2005 US$) in United Arab Emirates?
Offer a terse response. -1.56e+09. In the year 2006, what is the difference between the Value added (constant 2005 US$) of Uganda and Value added (constant 2005 US$) of United Arab Emirates?
Give a very brief answer. -3.21e+07. In the year 2007, what is the difference between the Value added (constant 2005 US$) of Low income and Value added (constant 2005 US$) of Namibia?
Offer a very short reply. 5.02e+1. In the year 2007, what is the difference between the Value added (constant 2005 US$) of Low income and Value added (constant 2005 US$) of Uganda?
Your answer should be very brief. 4.86e+1. In the year 2007, what is the difference between the Value added (constant 2005 US$) in Low income and Value added (constant 2005 US$) in United Arab Emirates?
Offer a terse response. 4.86e+1. In the year 2007, what is the difference between the Value added (constant 2005 US$) in Namibia and Value added (constant 2005 US$) in Uganda?
Keep it short and to the point. -1.63e+09. In the year 2007, what is the difference between the Value added (constant 2005 US$) in Namibia and Value added (constant 2005 US$) in United Arab Emirates?
Give a very brief answer. -1.62e+09. In the year 2007, what is the difference between the Value added (constant 2005 US$) in Uganda and Value added (constant 2005 US$) in United Arab Emirates?
Provide a succinct answer. 1.31e+07. In the year 2008, what is the difference between the Value added (constant 2005 US$) of Low income and Value added (constant 2005 US$) of Namibia?
Your answer should be very brief. 5.25e+1. In the year 2008, what is the difference between the Value added (constant 2005 US$) of Low income and Value added (constant 2005 US$) of Uganda?
Ensure brevity in your answer.  5.08e+1. In the year 2008, what is the difference between the Value added (constant 2005 US$) of Low income and Value added (constant 2005 US$) of United Arab Emirates?
Provide a short and direct response. 5.11e+1. In the year 2008, what is the difference between the Value added (constant 2005 US$) of Namibia and Value added (constant 2005 US$) of Uganda?
Your answer should be very brief. -1.76e+09. In the year 2008, what is the difference between the Value added (constant 2005 US$) in Namibia and Value added (constant 2005 US$) in United Arab Emirates?
Your response must be concise. -1.47e+09. In the year 2008, what is the difference between the Value added (constant 2005 US$) of Uganda and Value added (constant 2005 US$) of United Arab Emirates?
Keep it short and to the point. 2.90e+08. What is the ratio of the Value added (constant 2005 US$) in Namibia in 2001 to that in 2002?
Your answer should be very brief. 0.91. What is the ratio of the Value added (constant 2005 US$) of Uganda in 2001 to that in 2002?
Provide a short and direct response. 0.93. What is the ratio of the Value added (constant 2005 US$) of United Arab Emirates in 2001 to that in 2002?
Keep it short and to the point. 0.97. What is the ratio of the Value added (constant 2005 US$) of Low income in 2001 to that in 2003?
Your answer should be compact. 0.98. What is the ratio of the Value added (constant 2005 US$) in Namibia in 2001 to that in 2003?
Make the answer very short. 0.88. What is the ratio of the Value added (constant 2005 US$) in Uganda in 2001 to that in 2003?
Provide a short and direct response. 0.91. What is the ratio of the Value added (constant 2005 US$) of Low income in 2001 to that in 2004?
Ensure brevity in your answer.  0.96. What is the ratio of the Value added (constant 2005 US$) in Namibia in 2001 to that in 2004?
Offer a terse response. 0.87. What is the ratio of the Value added (constant 2005 US$) in Uganda in 2001 to that in 2004?
Your response must be concise. 0.9. What is the ratio of the Value added (constant 2005 US$) in United Arab Emirates in 2001 to that in 2004?
Provide a succinct answer. 1.02. What is the ratio of the Value added (constant 2005 US$) in Low income in 2001 to that in 2005?
Your answer should be compact. 0.9. What is the ratio of the Value added (constant 2005 US$) in Namibia in 2001 to that in 2005?
Your response must be concise. 0.83. What is the ratio of the Value added (constant 2005 US$) of Uganda in 2001 to that in 2005?
Your answer should be compact. 0.88. What is the ratio of the Value added (constant 2005 US$) in United Arab Emirates in 2001 to that in 2005?
Ensure brevity in your answer.  1.06. What is the ratio of the Value added (constant 2005 US$) of Low income in 2001 to that in 2006?
Keep it short and to the point. 0.87. What is the ratio of the Value added (constant 2005 US$) of Namibia in 2001 to that in 2006?
Give a very brief answer. 0.84. What is the ratio of the Value added (constant 2005 US$) of Uganda in 2001 to that in 2006?
Provide a succinct answer. 0.88. What is the ratio of the Value added (constant 2005 US$) of United Arab Emirates in 2001 to that in 2006?
Provide a short and direct response. 1.16. What is the ratio of the Value added (constant 2005 US$) in Low income in 2001 to that in 2007?
Ensure brevity in your answer.  0.83. What is the ratio of the Value added (constant 2005 US$) of Namibia in 2001 to that in 2007?
Offer a terse response. 0.98. What is the ratio of the Value added (constant 2005 US$) of Uganda in 2001 to that in 2007?
Provide a succinct answer. 0.88. What is the ratio of the Value added (constant 2005 US$) of United Arab Emirates in 2001 to that in 2007?
Offer a very short reply. 1.19. What is the ratio of the Value added (constant 2005 US$) in Low income in 2001 to that in 2008?
Your answer should be compact. 0.8. What is the ratio of the Value added (constant 2005 US$) of Namibia in 2001 to that in 2008?
Your response must be concise. 1.16. What is the ratio of the Value added (constant 2005 US$) of Uganda in 2001 to that in 2008?
Your response must be concise. 0.87. What is the ratio of the Value added (constant 2005 US$) in United Arab Emirates in 2001 to that in 2008?
Provide a short and direct response. 1.33. What is the ratio of the Value added (constant 2005 US$) of Low income in 2002 to that in 2003?
Your answer should be compact. 0.99. What is the ratio of the Value added (constant 2005 US$) in Namibia in 2002 to that in 2003?
Keep it short and to the point. 0.96. What is the ratio of the Value added (constant 2005 US$) of United Arab Emirates in 2002 to that in 2003?
Offer a very short reply. 1.03. What is the ratio of the Value added (constant 2005 US$) of Low income in 2002 to that in 2004?
Offer a terse response. 0.97. What is the ratio of the Value added (constant 2005 US$) in Namibia in 2002 to that in 2004?
Provide a succinct answer. 0.95. What is the ratio of the Value added (constant 2005 US$) in Uganda in 2002 to that in 2004?
Keep it short and to the point. 0.96. What is the ratio of the Value added (constant 2005 US$) in United Arab Emirates in 2002 to that in 2004?
Offer a very short reply. 1.05. What is the ratio of the Value added (constant 2005 US$) in Low income in 2002 to that in 2005?
Make the answer very short. 0.91. What is the ratio of the Value added (constant 2005 US$) in Namibia in 2002 to that in 2005?
Provide a succinct answer. 0.91. What is the ratio of the Value added (constant 2005 US$) of United Arab Emirates in 2002 to that in 2005?
Make the answer very short. 1.1. What is the ratio of the Value added (constant 2005 US$) of Low income in 2002 to that in 2006?
Give a very brief answer. 0.88. What is the ratio of the Value added (constant 2005 US$) of Namibia in 2002 to that in 2006?
Your answer should be very brief. 0.92. What is the ratio of the Value added (constant 2005 US$) of Uganda in 2002 to that in 2006?
Your answer should be very brief. 0.94. What is the ratio of the Value added (constant 2005 US$) in United Arab Emirates in 2002 to that in 2006?
Keep it short and to the point. 1.2. What is the ratio of the Value added (constant 2005 US$) in Low income in 2002 to that in 2007?
Offer a terse response. 0.84. What is the ratio of the Value added (constant 2005 US$) in Namibia in 2002 to that in 2007?
Provide a succinct answer. 1.07. What is the ratio of the Value added (constant 2005 US$) of Uganda in 2002 to that in 2007?
Keep it short and to the point. 0.94. What is the ratio of the Value added (constant 2005 US$) of United Arab Emirates in 2002 to that in 2007?
Keep it short and to the point. 1.22. What is the ratio of the Value added (constant 2005 US$) of Low income in 2002 to that in 2008?
Your answer should be very brief. 0.81. What is the ratio of the Value added (constant 2005 US$) of Namibia in 2002 to that in 2008?
Make the answer very short. 1.27. What is the ratio of the Value added (constant 2005 US$) of Uganda in 2002 to that in 2008?
Keep it short and to the point. 0.93. What is the ratio of the Value added (constant 2005 US$) in United Arab Emirates in 2002 to that in 2008?
Provide a short and direct response. 1.37. What is the ratio of the Value added (constant 2005 US$) in Low income in 2003 to that in 2004?
Provide a short and direct response. 0.98. What is the ratio of the Value added (constant 2005 US$) of Uganda in 2003 to that in 2004?
Give a very brief answer. 0.98. What is the ratio of the Value added (constant 2005 US$) of United Arab Emirates in 2003 to that in 2004?
Your answer should be compact. 1.02. What is the ratio of the Value added (constant 2005 US$) of Low income in 2003 to that in 2005?
Ensure brevity in your answer.  0.92. What is the ratio of the Value added (constant 2005 US$) in Namibia in 2003 to that in 2005?
Offer a very short reply. 0.95. What is the ratio of the Value added (constant 2005 US$) of Uganda in 2003 to that in 2005?
Your answer should be compact. 0.96. What is the ratio of the Value added (constant 2005 US$) in United Arab Emirates in 2003 to that in 2005?
Your answer should be compact. 1.06. What is the ratio of the Value added (constant 2005 US$) of Low income in 2003 to that in 2006?
Your answer should be compact. 0.88. What is the ratio of the Value added (constant 2005 US$) of Namibia in 2003 to that in 2006?
Your response must be concise. 0.96. What is the ratio of the Value added (constant 2005 US$) in Uganda in 2003 to that in 2006?
Provide a succinct answer. 0.96. What is the ratio of the Value added (constant 2005 US$) of United Arab Emirates in 2003 to that in 2006?
Make the answer very short. 1.16. What is the ratio of the Value added (constant 2005 US$) of Low income in 2003 to that in 2007?
Your response must be concise. 0.85. What is the ratio of the Value added (constant 2005 US$) of Namibia in 2003 to that in 2007?
Your response must be concise. 1.12. What is the ratio of the Value added (constant 2005 US$) in Uganda in 2003 to that in 2007?
Provide a short and direct response. 0.96. What is the ratio of the Value added (constant 2005 US$) in United Arab Emirates in 2003 to that in 2007?
Your response must be concise. 1.19. What is the ratio of the Value added (constant 2005 US$) in Low income in 2003 to that in 2008?
Provide a short and direct response. 0.81. What is the ratio of the Value added (constant 2005 US$) of Namibia in 2003 to that in 2008?
Your response must be concise. 1.33. What is the ratio of the Value added (constant 2005 US$) of Uganda in 2003 to that in 2008?
Give a very brief answer. 0.95. What is the ratio of the Value added (constant 2005 US$) of United Arab Emirates in 2003 to that in 2008?
Your answer should be compact. 1.33. What is the ratio of the Value added (constant 2005 US$) in Low income in 2004 to that in 2005?
Your answer should be compact. 0.94. What is the ratio of the Value added (constant 2005 US$) of Namibia in 2004 to that in 2005?
Keep it short and to the point. 0.96. What is the ratio of the Value added (constant 2005 US$) of Uganda in 2004 to that in 2005?
Your answer should be very brief. 0.98. What is the ratio of the Value added (constant 2005 US$) of United Arab Emirates in 2004 to that in 2005?
Offer a very short reply. 1.04. What is the ratio of the Value added (constant 2005 US$) of Low income in 2004 to that in 2006?
Ensure brevity in your answer.  0.91. What is the ratio of the Value added (constant 2005 US$) of Namibia in 2004 to that in 2006?
Offer a very short reply. 0.97. What is the ratio of the Value added (constant 2005 US$) in Uganda in 2004 to that in 2006?
Keep it short and to the point. 0.98. What is the ratio of the Value added (constant 2005 US$) of United Arab Emirates in 2004 to that in 2006?
Provide a short and direct response. 1.14. What is the ratio of the Value added (constant 2005 US$) of Low income in 2004 to that in 2007?
Offer a very short reply. 0.87. What is the ratio of the Value added (constant 2005 US$) in Namibia in 2004 to that in 2007?
Your response must be concise. 1.12. What is the ratio of the Value added (constant 2005 US$) in Uganda in 2004 to that in 2007?
Your answer should be very brief. 0.97. What is the ratio of the Value added (constant 2005 US$) of United Arab Emirates in 2004 to that in 2007?
Keep it short and to the point. 1.16. What is the ratio of the Value added (constant 2005 US$) of Low income in 2004 to that in 2008?
Your response must be concise. 0.83. What is the ratio of the Value added (constant 2005 US$) in Namibia in 2004 to that in 2008?
Ensure brevity in your answer.  1.34. What is the ratio of the Value added (constant 2005 US$) of Uganda in 2004 to that in 2008?
Your answer should be very brief. 0.96. What is the ratio of the Value added (constant 2005 US$) of United Arab Emirates in 2004 to that in 2008?
Offer a terse response. 1.3. What is the ratio of the Value added (constant 2005 US$) in Low income in 2005 to that in 2006?
Keep it short and to the point. 0.97. What is the ratio of the Value added (constant 2005 US$) in Namibia in 2005 to that in 2006?
Provide a short and direct response. 1.01. What is the ratio of the Value added (constant 2005 US$) in Uganda in 2005 to that in 2006?
Your answer should be very brief. 1. What is the ratio of the Value added (constant 2005 US$) in United Arab Emirates in 2005 to that in 2006?
Give a very brief answer. 1.09. What is the ratio of the Value added (constant 2005 US$) of Low income in 2005 to that in 2007?
Provide a short and direct response. 0.93. What is the ratio of the Value added (constant 2005 US$) of Namibia in 2005 to that in 2007?
Provide a short and direct response. 1.18. What is the ratio of the Value added (constant 2005 US$) in Uganda in 2005 to that in 2007?
Provide a succinct answer. 0.99. What is the ratio of the Value added (constant 2005 US$) in United Arab Emirates in 2005 to that in 2007?
Offer a very short reply. 1.12. What is the ratio of the Value added (constant 2005 US$) of Low income in 2005 to that in 2008?
Your answer should be compact. 0.89. What is the ratio of the Value added (constant 2005 US$) of Namibia in 2005 to that in 2008?
Make the answer very short. 1.4. What is the ratio of the Value added (constant 2005 US$) in United Arab Emirates in 2005 to that in 2008?
Provide a succinct answer. 1.25. What is the ratio of the Value added (constant 2005 US$) in Low income in 2006 to that in 2007?
Ensure brevity in your answer.  0.96. What is the ratio of the Value added (constant 2005 US$) in Namibia in 2006 to that in 2007?
Give a very brief answer. 1.16. What is the ratio of the Value added (constant 2005 US$) in Uganda in 2006 to that in 2007?
Provide a succinct answer. 1. What is the ratio of the Value added (constant 2005 US$) of United Arab Emirates in 2006 to that in 2007?
Your answer should be very brief. 1.02. What is the ratio of the Value added (constant 2005 US$) in Low income in 2006 to that in 2008?
Keep it short and to the point. 0.92. What is the ratio of the Value added (constant 2005 US$) in Namibia in 2006 to that in 2008?
Keep it short and to the point. 1.38. What is the ratio of the Value added (constant 2005 US$) in Uganda in 2006 to that in 2008?
Your answer should be compact. 0.99. What is the ratio of the Value added (constant 2005 US$) of United Arab Emirates in 2006 to that in 2008?
Offer a very short reply. 1.14. What is the ratio of the Value added (constant 2005 US$) in Low income in 2007 to that in 2008?
Make the answer very short. 0.96. What is the ratio of the Value added (constant 2005 US$) in Namibia in 2007 to that in 2008?
Your response must be concise. 1.19. What is the ratio of the Value added (constant 2005 US$) of Uganda in 2007 to that in 2008?
Make the answer very short. 0.99. What is the ratio of the Value added (constant 2005 US$) of United Arab Emirates in 2007 to that in 2008?
Your answer should be very brief. 1.12. What is the difference between the highest and the second highest Value added (constant 2005 US$) of Low income?
Offer a very short reply. 2.23e+09. What is the difference between the highest and the second highest Value added (constant 2005 US$) of Namibia?
Provide a short and direct response. 8.55e+06. What is the difference between the highest and the second highest Value added (constant 2005 US$) in Uganda?
Give a very brief answer. 3.06e+07. What is the difference between the highest and the second highest Value added (constant 2005 US$) of United Arab Emirates?
Give a very brief answer. 8.60e+07. What is the difference between the highest and the lowest Value added (constant 2005 US$) in Low income?
Offer a terse response. 1.07e+1. What is the difference between the highest and the lowest Value added (constant 2005 US$) in Namibia?
Keep it short and to the point. 2.15e+08. What is the difference between the highest and the lowest Value added (constant 2005 US$) of Uganda?
Offer a very short reply. 3.10e+08. What is the difference between the highest and the lowest Value added (constant 2005 US$) in United Arab Emirates?
Your response must be concise. 7.51e+08. 